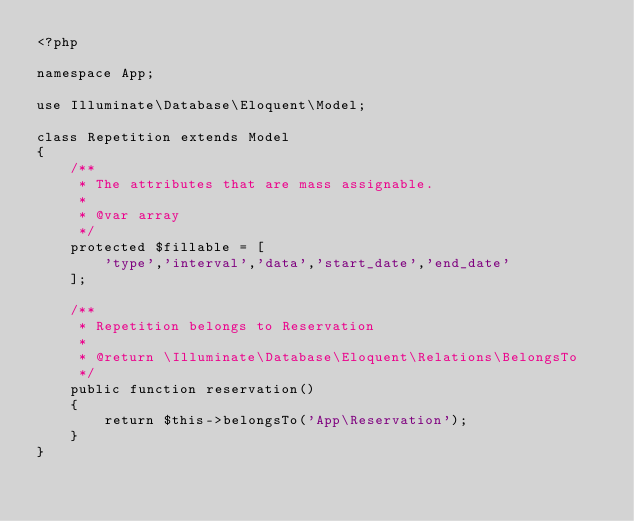<code> <loc_0><loc_0><loc_500><loc_500><_PHP_><?php

namespace App;

use Illuminate\Database\Eloquent\Model;

class Repetition extends Model
{
    /**
     * The attributes that are mass assignable.
     *
     * @var array
     */
    protected $fillable = [
        'type','interval','data','start_date','end_date'
    ];

    /**
     * Repetition belongs to Reservation
     *
     * @return \Illuminate\Database\Eloquent\Relations\BelongsTo
     */
    public function reservation()
    {
        return $this->belongsTo('App\Reservation');
    }
}
</code> 